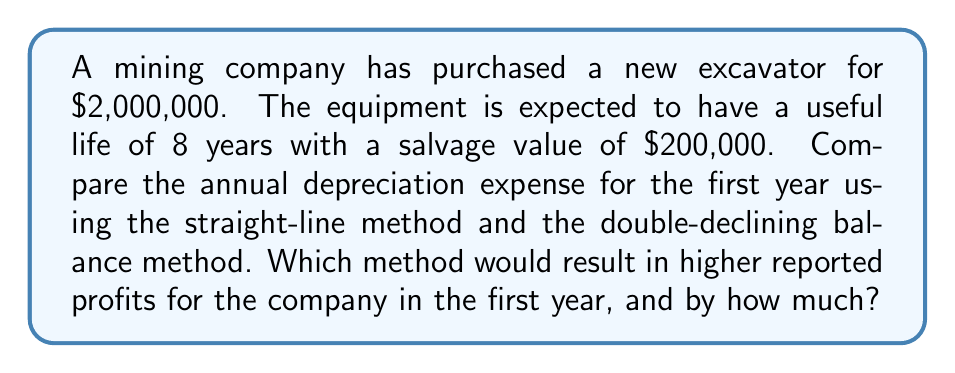Teach me how to tackle this problem. To solve this problem, we need to calculate the depreciation expense using both methods and compare the results.

1. Straight-line method:
The formula for annual depreciation using the straight-line method is:

$$ \text{Annual Depreciation} = \frac{\text{Cost} - \text{Salvage Value}}{\text{Useful Life}} $$

Plugging in the values:

$$ \text{Annual Depreciation} = \frac{\$2,000,000 - \$200,000}{8} = \$225,000 $$

2. Double-declining balance method:
First, we need to calculate the depreciation rate:

$$ \text{Depreciation Rate} = \frac{2}{\text{Useful Life}} = \frac{2}{8} = 25\% $$

The formula for the first year's depreciation using the double-declining balance method is:

$$ \text{First Year Depreciation} = \text{Cost} \times \text{Depreciation Rate} $$

Plugging in the values:

$$ \text{First Year Depreciation} = \$2,000,000 \times 25\% = \$500,000 $$

3. Comparison:
The difference in depreciation expense between the two methods is:

$$ \$500,000 - \$225,000 = \$275,000 $$

The double-declining balance method results in a higher depreciation expense in the first year. Since depreciation is an expense that reduces reported profits, the straight-line method would result in higher reported profits for the company in the first year.

The difference in reported profits would be equal to the difference in depreciation expense: $275,000.
Answer: The straight-line method would result in higher reported profits for the company in the first year by $275,000. 